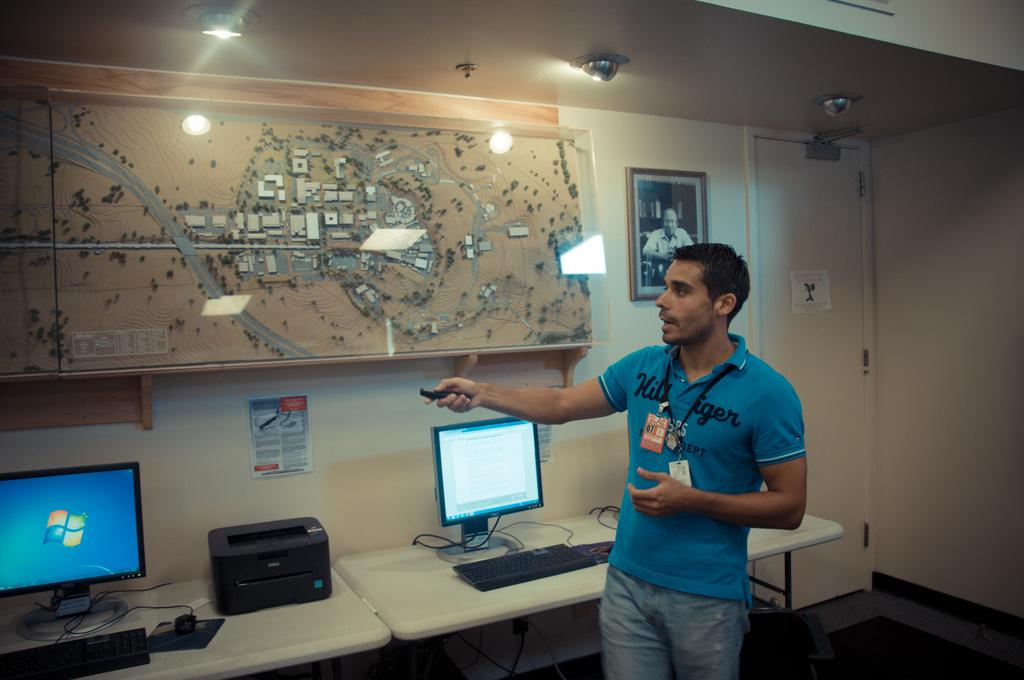Provide a one-sentence caption for the provided image. A man in a blue shirt with Hil on the upper left front side points a remote. 